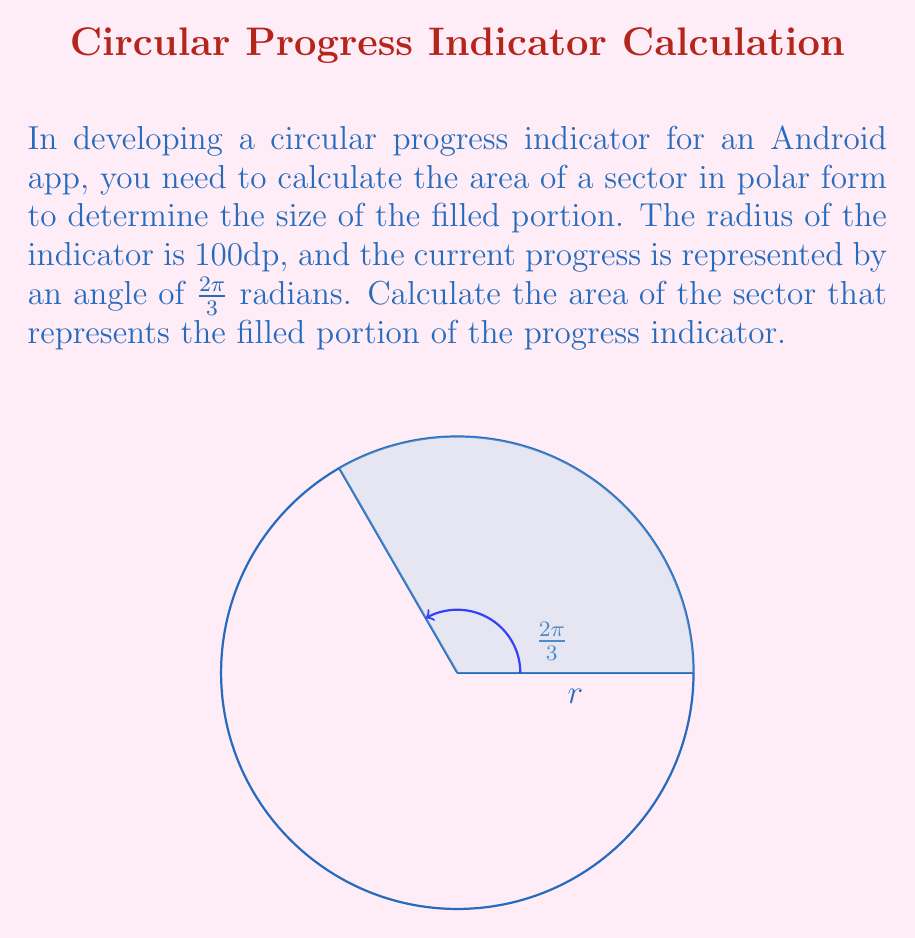Can you answer this question? To calculate the area of a sector in polar form, we use the formula:

$$A = \frac{1}{2} r^2 \theta$$

Where:
$A$ is the area of the sector
$r$ is the radius
$\theta$ is the central angle in radians

Given:
- Radius $r = 100$ dp
- Angle $\theta = \frac{2\pi}{3}$ radians

Step 1: Substitute the values into the formula
$$A = \frac{1}{2} \cdot (100)^2 \cdot \frac{2\pi}{3}$$

Step 2: Simplify
$$A = \frac{1}{2} \cdot 10000 \cdot \frac{2\pi}{3}$$
$$A = 5000 \cdot \frac{2\pi}{3}$$

Step 3: Calculate the final result
$$A = \frac{10000\pi}{3} \approx 10471.98$$

The area of the sector is approximately 10471.98 square dp.

Note: In Android development, you may need to convert this to pixels or other units depending on the device's screen density.
Answer: $\frac{10000\pi}{3}$ square dp 